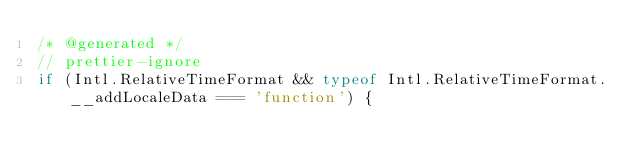Convert code to text. <code><loc_0><loc_0><loc_500><loc_500><_JavaScript_>/* @generated */	
// prettier-ignore
if (Intl.RelativeTimeFormat && typeof Intl.RelativeTimeFormat.__addLocaleData === 'function') {</code> 